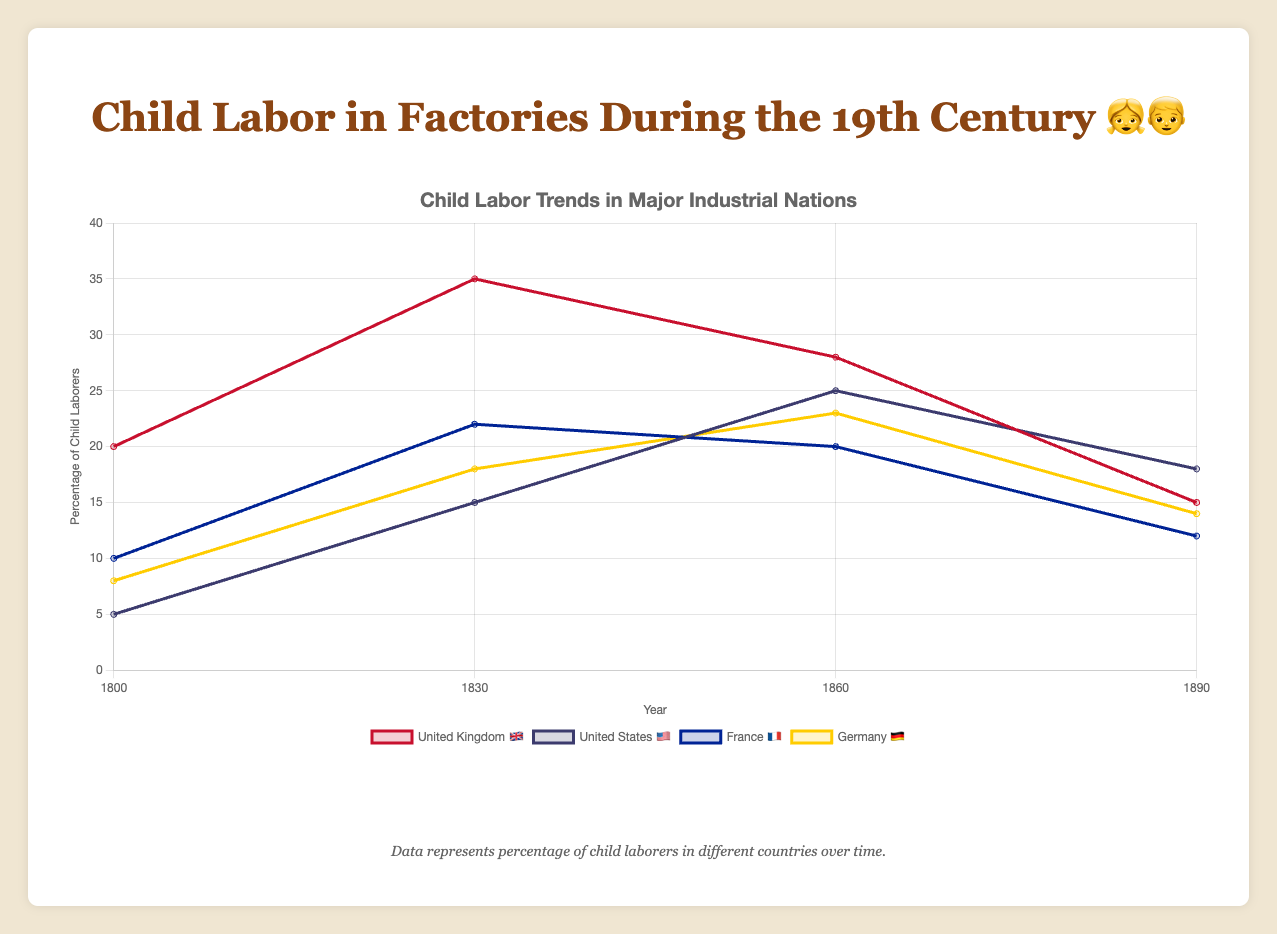What is the title of the chart? The title is usually found at the top of the chart, indicating its main subject. In this case, it is "Child Labor in Factories During the 19th Century 👧👦"
Answer: Child Labor in Factories During the 19th Century 👧👦 What years are represented on the horizontal axis? The horizontal axis shows the time periods included in the chart. The years listed are 1800, 1830, 1860, and 1890
Answer: 1800, 1830, 1860, 1890 Which country had the highest percentage of child labor in 1830? To find this, look at the data values for each country in 1830. The United Kingdom 🇬🇧 had the highest with 35%
Answer: United Kingdom 🇬🇧 How did the percentage of child labor in Germany 🇩🇪 change from 1800 to 1890? Calculating the difference in percentages from 1800 (8%) to 1890 (14%) shows an increase of 6% (14% - 8%)
Answer: Increased by 6% Which industry employed the most child laborers according to the pie chart? According to the pie chart data, Textile Mills 🧵 had the highest percentage at 40%
Answer: Textile Mills 🧵 What is the difference in child labor percentage between France 🇫🇷 and the United States 🇺🇸 in 1890? In 1890, France 🇫🇷 had 12% and the United States 🇺🇸 had 18%. The difference is 18% - 12% = 6%
Answer: 6% Which country had the least change in child labor percentages from 1800 to 1890? Calculating the change for each country, the United Kingdom 🇬🇧 had a change of 5% (20% - 15%), the United States 🇺🇸 had a change of 13% (18% - 5%), France 🇫🇷 had a change of 2%, and Germany 🇩🇪 had a change of 6%. France 🇫🇷 had the least change.
Answer: France 🇫🇷 In 1860, which country had the smallest percentage of child labor? In 1860, the percentages are United Kingdom 🇬🇧 (28%), United States 🇺🇸 (25%), France 🇫🇷 (20%), and Germany 🇩🇪 (23%). France 🇫🇷 had the smallest percentage with 20%
Answer: France 🇫🇷 